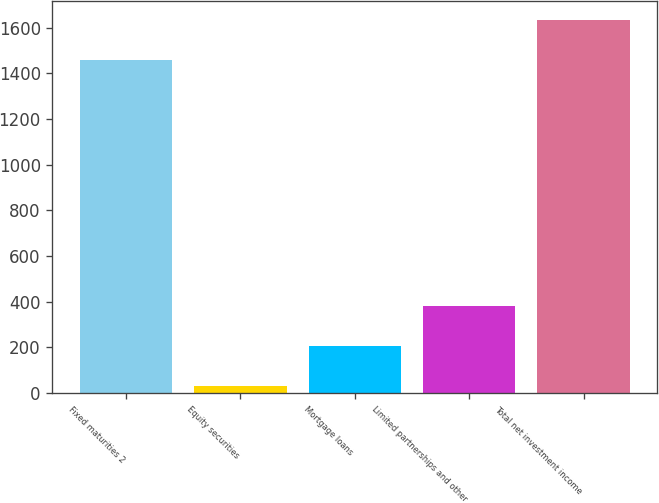Convert chart. <chart><loc_0><loc_0><loc_500><loc_500><bar_chart><fcel>Fixed maturities 2<fcel>Equity securities<fcel>Mortgage loans<fcel>Limited partnerships and other<fcel>Total net investment income<nl><fcel>1459<fcel>32<fcel>206.8<fcel>381.6<fcel>1633.8<nl></chart> 